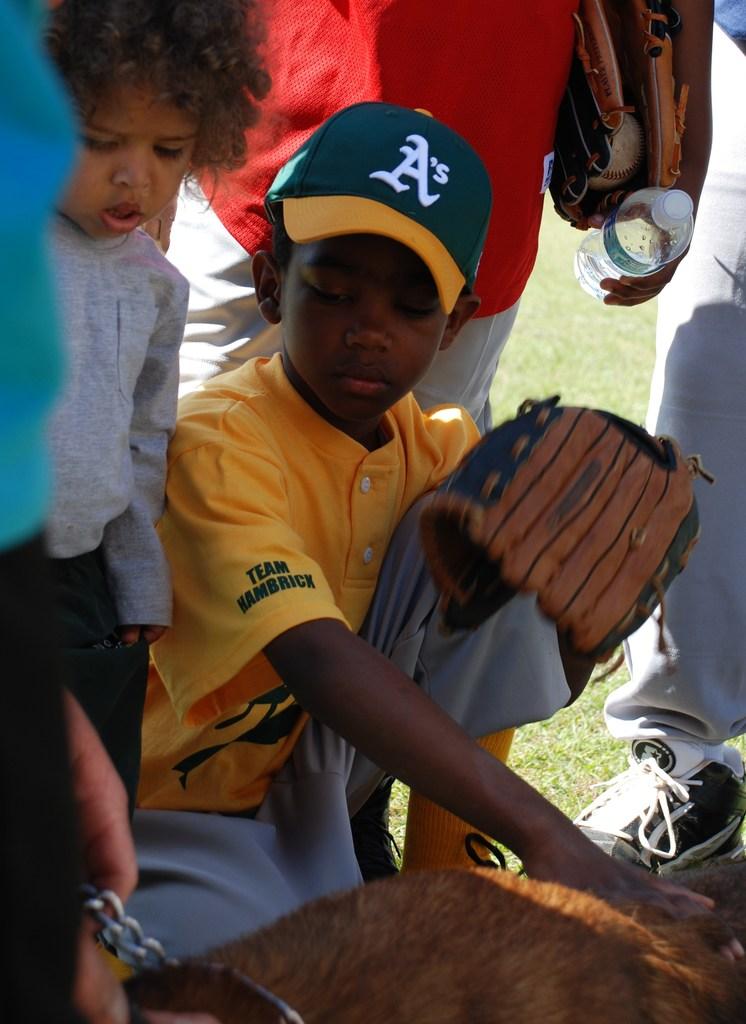What letter is present on the boy's hat?
Provide a succinct answer. A. What team is the player on?
Your response must be concise. A's. 